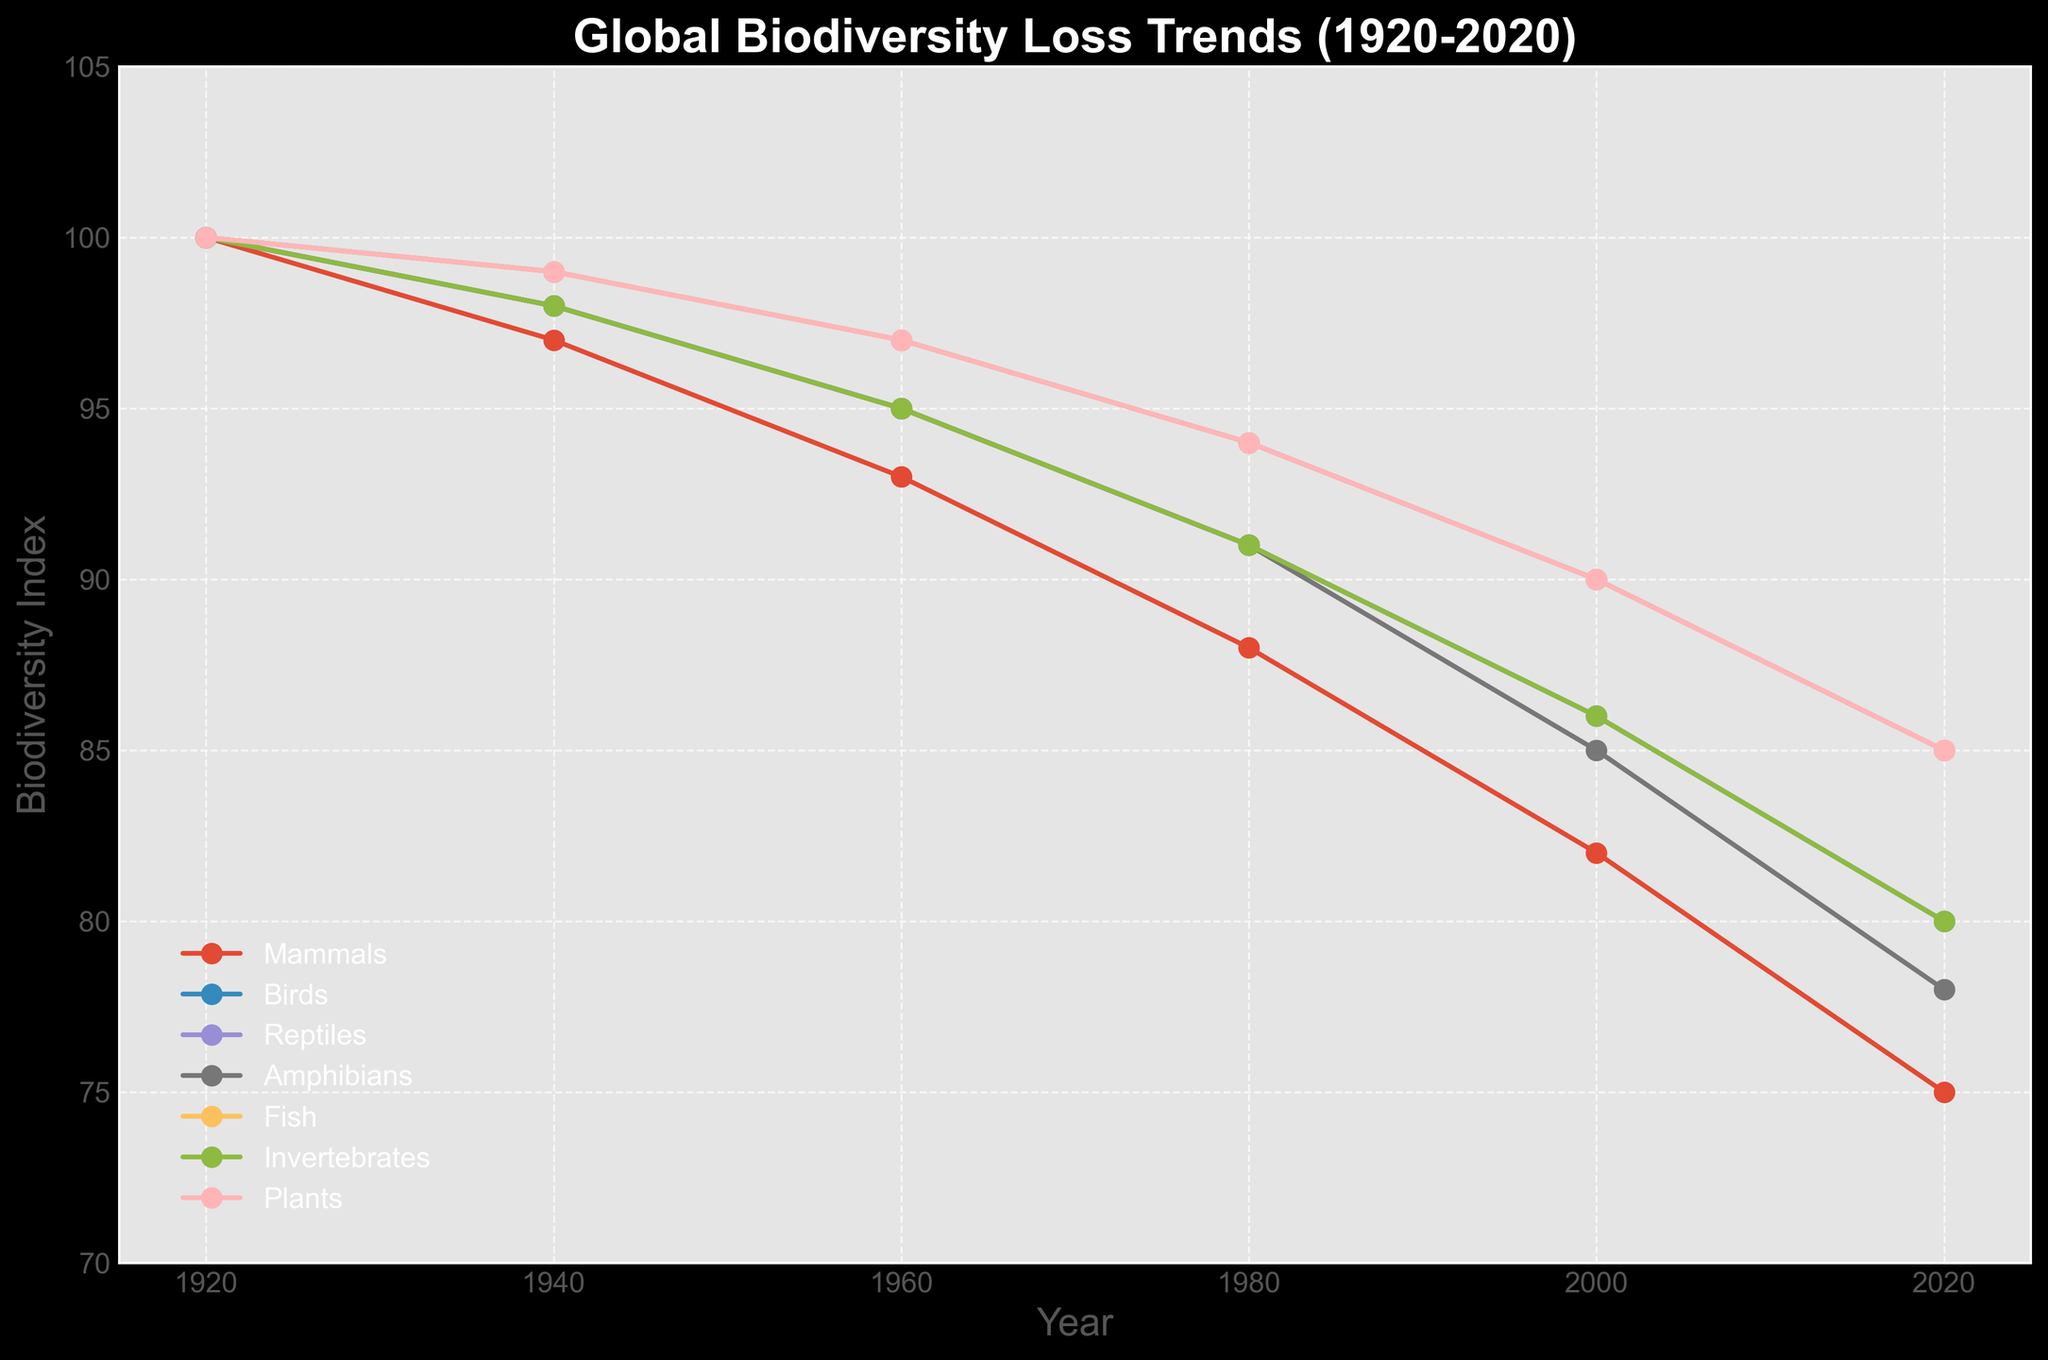What major taxonomic group exhibits the highest biodiversity index in 2020? By examining the plot, check the data points for each group in 2020. The line representing Birds tops the chart at 80.
Answer: Birds Which group shows the most consistent decline over the years? Look at the steepness and linearity of the slope for each group from 1920 to 2020. Mammals display a more consistent and steeper decline than the other groups.
Answer: Mammals How many taxonomic groups have a biodiversity index less than 90 in 1980? Locate the 1980 data points and count the groups below the 90 mark. Six groups (Mammals, Birds, Reptiles, Amphibians, Fish, and Invertebrates) dip below 90 in 1980.
Answer: Six What is the overall percentage decline in amphibians' biodiversity index from 1920 to 2020? Calculate the difference between 1920 and 2020 values: 100 - 78 = 22, then divide by the original value and multiply by 100: (22/100) * 100 = 22%.
Answer: 22% Which group had the largest drop in biodiversity index between 2000 and 2020? Compare the drop from 2000 to 2020 across all groups. Mammals drop from 82 to 75, a difference of 7, the largest observed drop.
Answer: Mammals Is the biodiversity index for plants in 2020 higher or lower than that for fish? Compare the plot points for plants and fish in 2020. Both plants and fish have the same biodiversity index, which is 85.
Answer: Equal Which groups have a biodiversity index lower than 85 in the year 2000? Check the values for each group in 2000 and see which ones fall below 85. Mammals and Amphibians fall below 85.
Answer: Mammals and Amphibians What is the average biodiversity index of all groups in 2020? Sum the 2020 values (75+80+85+78+85+80+85 = 568), then divide by the total number of groups (7): 568/7 ≈ 81.14.
Answer: 81.14 By how much did mammals' biodiversity index decline between each recorded decade? Calculate the changes between data points for mammals: 1920-1940: 100-97=3, 1940-1960: 97-93=4, 1960-1980: 93-88=5, 1980-2000: 88-82=6, 2000-2020: 82-75=7.
Answer: 3, 4, 5, 6, 7 